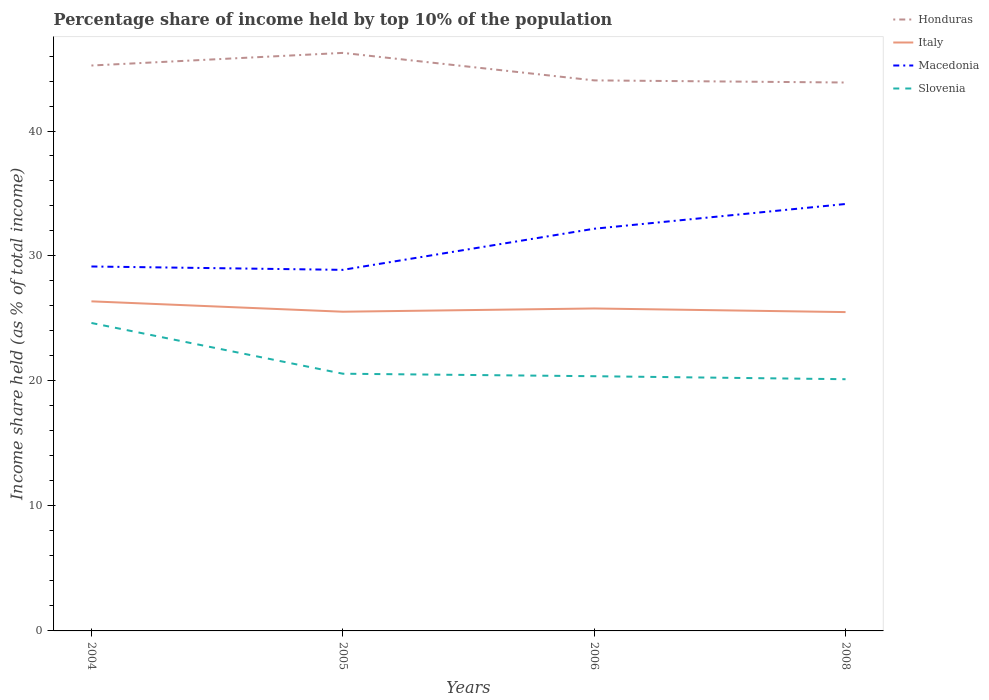Across all years, what is the maximum percentage share of income held by top 10% of the population in Slovenia?
Provide a short and direct response. 20.14. What is the total percentage share of income held by top 10% of the population in Honduras in the graph?
Provide a short and direct response. 2.37. What is the difference between the highest and the lowest percentage share of income held by top 10% of the population in Italy?
Your answer should be very brief. 1. Is the percentage share of income held by top 10% of the population in Honduras strictly greater than the percentage share of income held by top 10% of the population in Slovenia over the years?
Give a very brief answer. No. Does the graph contain any zero values?
Provide a succinct answer. No. How are the legend labels stacked?
Provide a short and direct response. Vertical. What is the title of the graph?
Offer a very short reply. Percentage share of income held by top 10% of the population. Does "Guinea" appear as one of the legend labels in the graph?
Give a very brief answer. No. What is the label or title of the Y-axis?
Provide a short and direct response. Income share held (as % of total income). What is the Income share held (as % of total income) in Honduras in 2004?
Give a very brief answer. 45.24. What is the Income share held (as % of total income) in Italy in 2004?
Provide a short and direct response. 26.37. What is the Income share held (as % of total income) of Macedonia in 2004?
Offer a very short reply. 29.16. What is the Income share held (as % of total income) of Slovenia in 2004?
Your answer should be compact. 24.64. What is the Income share held (as % of total income) in Honduras in 2005?
Your answer should be very brief. 46.25. What is the Income share held (as % of total income) in Italy in 2005?
Offer a terse response. 25.54. What is the Income share held (as % of total income) of Macedonia in 2005?
Offer a terse response. 28.89. What is the Income share held (as % of total income) in Slovenia in 2005?
Keep it short and to the point. 20.58. What is the Income share held (as % of total income) of Honduras in 2006?
Provide a short and direct response. 44.05. What is the Income share held (as % of total income) in Italy in 2006?
Give a very brief answer. 25.8. What is the Income share held (as % of total income) of Macedonia in 2006?
Provide a short and direct response. 32.18. What is the Income share held (as % of total income) in Slovenia in 2006?
Ensure brevity in your answer.  20.38. What is the Income share held (as % of total income) of Honduras in 2008?
Your answer should be very brief. 43.88. What is the Income share held (as % of total income) of Italy in 2008?
Your answer should be compact. 25.51. What is the Income share held (as % of total income) in Macedonia in 2008?
Ensure brevity in your answer.  34.16. What is the Income share held (as % of total income) in Slovenia in 2008?
Offer a very short reply. 20.14. Across all years, what is the maximum Income share held (as % of total income) in Honduras?
Your answer should be compact. 46.25. Across all years, what is the maximum Income share held (as % of total income) in Italy?
Offer a very short reply. 26.37. Across all years, what is the maximum Income share held (as % of total income) in Macedonia?
Offer a very short reply. 34.16. Across all years, what is the maximum Income share held (as % of total income) in Slovenia?
Give a very brief answer. 24.64. Across all years, what is the minimum Income share held (as % of total income) in Honduras?
Make the answer very short. 43.88. Across all years, what is the minimum Income share held (as % of total income) of Italy?
Offer a very short reply. 25.51. Across all years, what is the minimum Income share held (as % of total income) in Macedonia?
Your answer should be compact. 28.89. Across all years, what is the minimum Income share held (as % of total income) in Slovenia?
Make the answer very short. 20.14. What is the total Income share held (as % of total income) in Honduras in the graph?
Your response must be concise. 179.42. What is the total Income share held (as % of total income) of Italy in the graph?
Offer a very short reply. 103.22. What is the total Income share held (as % of total income) in Macedonia in the graph?
Your answer should be very brief. 124.39. What is the total Income share held (as % of total income) of Slovenia in the graph?
Provide a succinct answer. 85.74. What is the difference between the Income share held (as % of total income) of Honduras in 2004 and that in 2005?
Offer a very short reply. -1.01. What is the difference between the Income share held (as % of total income) of Italy in 2004 and that in 2005?
Provide a succinct answer. 0.83. What is the difference between the Income share held (as % of total income) in Macedonia in 2004 and that in 2005?
Provide a short and direct response. 0.27. What is the difference between the Income share held (as % of total income) in Slovenia in 2004 and that in 2005?
Your answer should be very brief. 4.06. What is the difference between the Income share held (as % of total income) of Honduras in 2004 and that in 2006?
Your answer should be compact. 1.19. What is the difference between the Income share held (as % of total income) of Italy in 2004 and that in 2006?
Offer a terse response. 0.57. What is the difference between the Income share held (as % of total income) of Macedonia in 2004 and that in 2006?
Give a very brief answer. -3.02. What is the difference between the Income share held (as % of total income) in Slovenia in 2004 and that in 2006?
Provide a succinct answer. 4.26. What is the difference between the Income share held (as % of total income) of Honduras in 2004 and that in 2008?
Your answer should be very brief. 1.36. What is the difference between the Income share held (as % of total income) in Italy in 2004 and that in 2008?
Offer a terse response. 0.86. What is the difference between the Income share held (as % of total income) in Slovenia in 2004 and that in 2008?
Your response must be concise. 4.5. What is the difference between the Income share held (as % of total income) in Italy in 2005 and that in 2006?
Your answer should be compact. -0.26. What is the difference between the Income share held (as % of total income) in Macedonia in 2005 and that in 2006?
Your answer should be very brief. -3.29. What is the difference between the Income share held (as % of total income) of Honduras in 2005 and that in 2008?
Make the answer very short. 2.37. What is the difference between the Income share held (as % of total income) of Macedonia in 2005 and that in 2008?
Your response must be concise. -5.27. What is the difference between the Income share held (as % of total income) of Slovenia in 2005 and that in 2008?
Give a very brief answer. 0.44. What is the difference between the Income share held (as % of total income) of Honduras in 2006 and that in 2008?
Make the answer very short. 0.17. What is the difference between the Income share held (as % of total income) in Italy in 2006 and that in 2008?
Keep it short and to the point. 0.29. What is the difference between the Income share held (as % of total income) in Macedonia in 2006 and that in 2008?
Your answer should be compact. -1.98. What is the difference between the Income share held (as % of total income) of Slovenia in 2006 and that in 2008?
Provide a succinct answer. 0.24. What is the difference between the Income share held (as % of total income) of Honduras in 2004 and the Income share held (as % of total income) of Macedonia in 2005?
Offer a terse response. 16.35. What is the difference between the Income share held (as % of total income) of Honduras in 2004 and the Income share held (as % of total income) of Slovenia in 2005?
Provide a succinct answer. 24.66. What is the difference between the Income share held (as % of total income) of Italy in 2004 and the Income share held (as % of total income) of Macedonia in 2005?
Ensure brevity in your answer.  -2.52. What is the difference between the Income share held (as % of total income) of Italy in 2004 and the Income share held (as % of total income) of Slovenia in 2005?
Offer a terse response. 5.79. What is the difference between the Income share held (as % of total income) of Macedonia in 2004 and the Income share held (as % of total income) of Slovenia in 2005?
Make the answer very short. 8.58. What is the difference between the Income share held (as % of total income) in Honduras in 2004 and the Income share held (as % of total income) in Italy in 2006?
Your response must be concise. 19.44. What is the difference between the Income share held (as % of total income) of Honduras in 2004 and the Income share held (as % of total income) of Macedonia in 2006?
Provide a succinct answer. 13.06. What is the difference between the Income share held (as % of total income) in Honduras in 2004 and the Income share held (as % of total income) in Slovenia in 2006?
Offer a very short reply. 24.86. What is the difference between the Income share held (as % of total income) of Italy in 2004 and the Income share held (as % of total income) of Macedonia in 2006?
Your answer should be compact. -5.81. What is the difference between the Income share held (as % of total income) of Italy in 2004 and the Income share held (as % of total income) of Slovenia in 2006?
Give a very brief answer. 5.99. What is the difference between the Income share held (as % of total income) in Macedonia in 2004 and the Income share held (as % of total income) in Slovenia in 2006?
Offer a terse response. 8.78. What is the difference between the Income share held (as % of total income) in Honduras in 2004 and the Income share held (as % of total income) in Italy in 2008?
Offer a terse response. 19.73. What is the difference between the Income share held (as % of total income) of Honduras in 2004 and the Income share held (as % of total income) of Macedonia in 2008?
Provide a succinct answer. 11.08. What is the difference between the Income share held (as % of total income) in Honduras in 2004 and the Income share held (as % of total income) in Slovenia in 2008?
Your answer should be compact. 25.1. What is the difference between the Income share held (as % of total income) of Italy in 2004 and the Income share held (as % of total income) of Macedonia in 2008?
Your response must be concise. -7.79. What is the difference between the Income share held (as % of total income) of Italy in 2004 and the Income share held (as % of total income) of Slovenia in 2008?
Your answer should be compact. 6.23. What is the difference between the Income share held (as % of total income) of Macedonia in 2004 and the Income share held (as % of total income) of Slovenia in 2008?
Give a very brief answer. 9.02. What is the difference between the Income share held (as % of total income) of Honduras in 2005 and the Income share held (as % of total income) of Italy in 2006?
Offer a terse response. 20.45. What is the difference between the Income share held (as % of total income) of Honduras in 2005 and the Income share held (as % of total income) of Macedonia in 2006?
Your response must be concise. 14.07. What is the difference between the Income share held (as % of total income) in Honduras in 2005 and the Income share held (as % of total income) in Slovenia in 2006?
Provide a succinct answer. 25.87. What is the difference between the Income share held (as % of total income) of Italy in 2005 and the Income share held (as % of total income) of Macedonia in 2006?
Your answer should be compact. -6.64. What is the difference between the Income share held (as % of total income) in Italy in 2005 and the Income share held (as % of total income) in Slovenia in 2006?
Offer a terse response. 5.16. What is the difference between the Income share held (as % of total income) of Macedonia in 2005 and the Income share held (as % of total income) of Slovenia in 2006?
Keep it short and to the point. 8.51. What is the difference between the Income share held (as % of total income) in Honduras in 2005 and the Income share held (as % of total income) in Italy in 2008?
Make the answer very short. 20.74. What is the difference between the Income share held (as % of total income) of Honduras in 2005 and the Income share held (as % of total income) of Macedonia in 2008?
Offer a very short reply. 12.09. What is the difference between the Income share held (as % of total income) in Honduras in 2005 and the Income share held (as % of total income) in Slovenia in 2008?
Ensure brevity in your answer.  26.11. What is the difference between the Income share held (as % of total income) in Italy in 2005 and the Income share held (as % of total income) in Macedonia in 2008?
Keep it short and to the point. -8.62. What is the difference between the Income share held (as % of total income) of Italy in 2005 and the Income share held (as % of total income) of Slovenia in 2008?
Your answer should be very brief. 5.4. What is the difference between the Income share held (as % of total income) of Macedonia in 2005 and the Income share held (as % of total income) of Slovenia in 2008?
Your answer should be compact. 8.75. What is the difference between the Income share held (as % of total income) of Honduras in 2006 and the Income share held (as % of total income) of Italy in 2008?
Offer a terse response. 18.54. What is the difference between the Income share held (as % of total income) in Honduras in 2006 and the Income share held (as % of total income) in Macedonia in 2008?
Give a very brief answer. 9.89. What is the difference between the Income share held (as % of total income) of Honduras in 2006 and the Income share held (as % of total income) of Slovenia in 2008?
Offer a very short reply. 23.91. What is the difference between the Income share held (as % of total income) in Italy in 2006 and the Income share held (as % of total income) in Macedonia in 2008?
Your response must be concise. -8.36. What is the difference between the Income share held (as % of total income) of Italy in 2006 and the Income share held (as % of total income) of Slovenia in 2008?
Offer a terse response. 5.66. What is the difference between the Income share held (as % of total income) of Macedonia in 2006 and the Income share held (as % of total income) of Slovenia in 2008?
Provide a short and direct response. 12.04. What is the average Income share held (as % of total income) in Honduras per year?
Make the answer very short. 44.85. What is the average Income share held (as % of total income) in Italy per year?
Your response must be concise. 25.8. What is the average Income share held (as % of total income) in Macedonia per year?
Your answer should be very brief. 31.1. What is the average Income share held (as % of total income) of Slovenia per year?
Your response must be concise. 21.43. In the year 2004, what is the difference between the Income share held (as % of total income) of Honduras and Income share held (as % of total income) of Italy?
Provide a succinct answer. 18.87. In the year 2004, what is the difference between the Income share held (as % of total income) in Honduras and Income share held (as % of total income) in Macedonia?
Provide a succinct answer. 16.08. In the year 2004, what is the difference between the Income share held (as % of total income) in Honduras and Income share held (as % of total income) in Slovenia?
Provide a succinct answer. 20.6. In the year 2004, what is the difference between the Income share held (as % of total income) in Italy and Income share held (as % of total income) in Macedonia?
Keep it short and to the point. -2.79. In the year 2004, what is the difference between the Income share held (as % of total income) of Italy and Income share held (as % of total income) of Slovenia?
Your response must be concise. 1.73. In the year 2004, what is the difference between the Income share held (as % of total income) of Macedonia and Income share held (as % of total income) of Slovenia?
Offer a terse response. 4.52. In the year 2005, what is the difference between the Income share held (as % of total income) in Honduras and Income share held (as % of total income) in Italy?
Offer a terse response. 20.71. In the year 2005, what is the difference between the Income share held (as % of total income) in Honduras and Income share held (as % of total income) in Macedonia?
Make the answer very short. 17.36. In the year 2005, what is the difference between the Income share held (as % of total income) in Honduras and Income share held (as % of total income) in Slovenia?
Provide a short and direct response. 25.67. In the year 2005, what is the difference between the Income share held (as % of total income) in Italy and Income share held (as % of total income) in Macedonia?
Your response must be concise. -3.35. In the year 2005, what is the difference between the Income share held (as % of total income) of Italy and Income share held (as % of total income) of Slovenia?
Your answer should be compact. 4.96. In the year 2005, what is the difference between the Income share held (as % of total income) of Macedonia and Income share held (as % of total income) of Slovenia?
Your answer should be very brief. 8.31. In the year 2006, what is the difference between the Income share held (as % of total income) of Honduras and Income share held (as % of total income) of Italy?
Your response must be concise. 18.25. In the year 2006, what is the difference between the Income share held (as % of total income) in Honduras and Income share held (as % of total income) in Macedonia?
Provide a succinct answer. 11.87. In the year 2006, what is the difference between the Income share held (as % of total income) of Honduras and Income share held (as % of total income) of Slovenia?
Provide a succinct answer. 23.67. In the year 2006, what is the difference between the Income share held (as % of total income) of Italy and Income share held (as % of total income) of Macedonia?
Offer a very short reply. -6.38. In the year 2006, what is the difference between the Income share held (as % of total income) of Italy and Income share held (as % of total income) of Slovenia?
Keep it short and to the point. 5.42. In the year 2008, what is the difference between the Income share held (as % of total income) in Honduras and Income share held (as % of total income) in Italy?
Keep it short and to the point. 18.37. In the year 2008, what is the difference between the Income share held (as % of total income) in Honduras and Income share held (as % of total income) in Macedonia?
Your response must be concise. 9.72. In the year 2008, what is the difference between the Income share held (as % of total income) in Honduras and Income share held (as % of total income) in Slovenia?
Offer a terse response. 23.74. In the year 2008, what is the difference between the Income share held (as % of total income) in Italy and Income share held (as % of total income) in Macedonia?
Give a very brief answer. -8.65. In the year 2008, what is the difference between the Income share held (as % of total income) of Italy and Income share held (as % of total income) of Slovenia?
Your answer should be very brief. 5.37. In the year 2008, what is the difference between the Income share held (as % of total income) in Macedonia and Income share held (as % of total income) in Slovenia?
Ensure brevity in your answer.  14.02. What is the ratio of the Income share held (as % of total income) in Honduras in 2004 to that in 2005?
Offer a very short reply. 0.98. What is the ratio of the Income share held (as % of total income) in Italy in 2004 to that in 2005?
Ensure brevity in your answer.  1.03. What is the ratio of the Income share held (as % of total income) in Macedonia in 2004 to that in 2005?
Offer a very short reply. 1.01. What is the ratio of the Income share held (as % of total income) of Slovenia in 2004 to that in 2005?
Ensure brevity in your answer.  1.2. What is the ratio of the Income share held (as % of total income) of Italy in 2004 to that in 2006?
Provide a short and direct response. 1.02. What is the ratio of the Income share held (as % of total income) of Macedonia in 2004 to that in 2006?
Ensure brevity in your answer.  0.91. What is the ratio of the Income share held (as % of total income) in Slovenia in 2004 to that in 2006?
Ensure brevity in your answer.  1.21. What is the ratio of the Income share held (as % of total income) of Honduras in 2004 to that in 2008?
Your answer should be very brief. 1.03. What is the ratio of the Income share held (as % of total income) of Italy in 2004 to that in 2008?
Offer a very short reply. 1.03. What is the ratio of the Income share held (as % of total income) in Macedonia in 2004 to that in 2008?
Provide a succinct answer. 0.85. What is the ratio of the Income share held (as % of total income) of Slovenia in 2004 to that in 2008?
Provide a succinct answer. 1.22. What is the ratio of the Income share held (as % of total income) of Honduras in 2005 to that in 2006?
Ensure brevity in your answer.  1.05. What is the ratio of the Income share held (as % of total income) in Macedonia in 2005 to that in 2006?
Your answer should be compact. 0.9. What is the ratio of the Income share held (as % of total income) in Slovenia in 2005 to that in 2006?
Offer a terse response. 1.01. What is the ratio of the Income share held (as % of total income) of Honduras in 2005 to that in 2008?
Offer a terse response. 1.05. What is the ratio of the Income share held (as % of total income) of Macedonia in 2005 to that in 2008?
Ensure brevity in your answer.  0.85. What is the ratio of the Income share held (as % of total income) of Slovenia in 2005 to that in 2008?
Offer a very short reply. 1.02. What is the ratio of the Income share held (as % of total income) of Italy in 2006 to that in 2008?
Keep it short and to the point. 1.01. What is the ratio of the Income share held (as % of total income) in Macedonia in 2006 to that in 2008?
Your answer should be compact. 0.94. What is the ratio of the Income share held (as % of total income) in Slovenia in 2006 to that in 2008?
Keep it short and to the point. 1.01. What is the difference between the highest and the second highest Income share held (as % of total income) in Italy?
Your answer should be very brief. 0.57. What is the difference between the highest and the second highest Income share held (as % of total income) in Macedonia?
Give a very brief answer. 1.98. What is the difference between the highest and the second highest Income share held (as % of total income) in Slovenia?
Keep it short and to the point. 4.06. What is the difference between the highest and the lowest Income share held (as % of total income) in Honduras?
Offer a terse response. 2.37. What is the difference between the highest and the lowest Income share held (as % of total income) in Italy?
Make the answer very short. 0.86. What is the difference between the highest and the lowest Income share held (as % of total income) of Macedonia?
Your answer should be very brief. 5.27. 